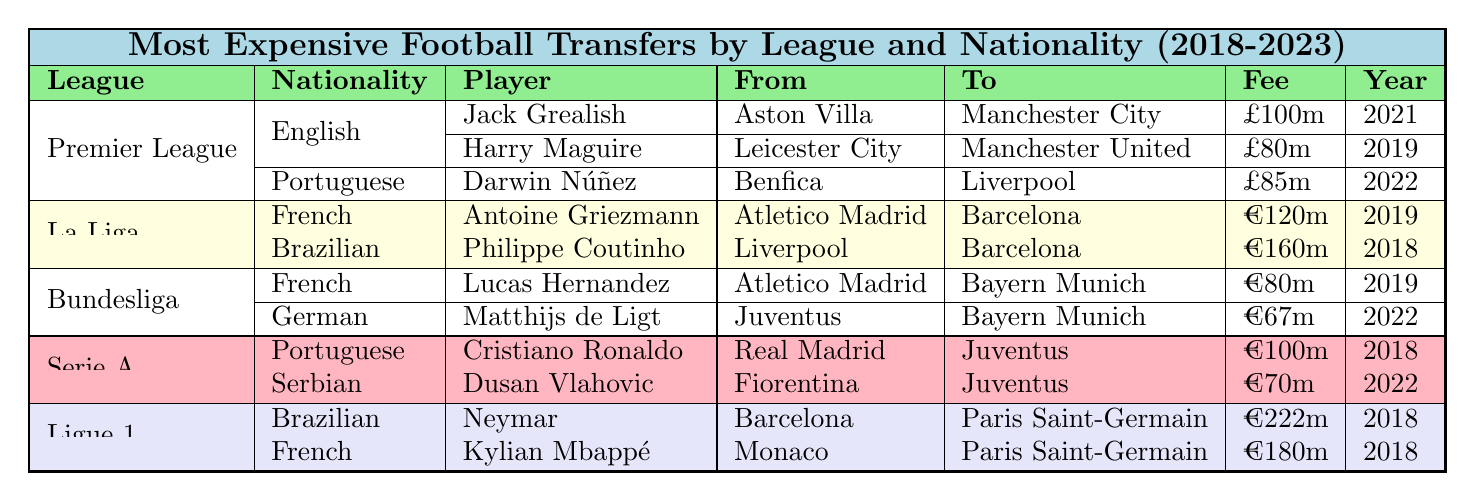What is the most expensive football transfer in the Ligue 1? The most expensive transfer in Ligue 1 is Neymar, who moved from Barcelona to Paris Saint-Germain for €222m in 2018.
Answer: Neymar How many players transferred from Atletico Madrid? There are three players who transferred from Atletico Madrid: Lucas Hernandez to Bayern Munich, Antoine Griezmann to Barcelona, and Jack Grealish indirectly related as he transferred from Aston Villa where he previously competed against Atletico.
Answer: Three Is there any player from the Bundesliga who transferred for more than €80m? Yes, Lucas Hernandez transferred from Atletico Madrid to Bayern Munich for €80m. Matthijs de Ligt transferred for €67m, which is less.
Answer: Yes What is the total transfer fee for all players from the Premier League listed in the table? The total fee is £100m (Jack Grealish) + £80m (Harry Maguire) + £85m (Darwin Núñez) = £265m.
Answer: £265m Which league has the highest total transfer fee and what is that total? Ligue 1 has the highest total transfer fee: €222m (Neymar) + €180m (Kylian Mbappé) = €402m.
Answer: €402m Were there any Brazilian players transferred in La Liga between 2018 and 2023? Yes, Philippe Coutinho is a Brazilian player who transferred from Liverpool to Barcelona for €160m in 2018.
Answer: Yes How many transfers involved French players across all leagues? There are three transfers involving French players: Antoine Griezmann (La Liga), Lucas Hernandez (Bundesliga), and Kylian Mbappé (Ligue 1).
Answer: Three Which player had the highest transfer fee in Serie A and what was the fee? Cristiano Ronaldo had the highest transfer fee in Serie A at €100m, moving from Real Madrid to Juventus in 2018.
Answer: €100m What are the nationalities of the Bundesliga players listed? The Bundesliga players listed are French (Lucas Hernandez) and German (Matthijs de Ligt).
Answer: French and German Is there any player from the Premier League who transferred to Manchester City? Yes, Jack Grealish transferred from Aston Villa to Manchester City for £100m in 2021.
Answer: Yes What is the average transfer fee of all the players in La Liga? The total transfer fee for La Liga players is €120m (Antoine Griezmann) + €160m (Philippe Coutinho) = €280m. The average for 2 players is €280m / 2 = €140m.
Answer: €140m 